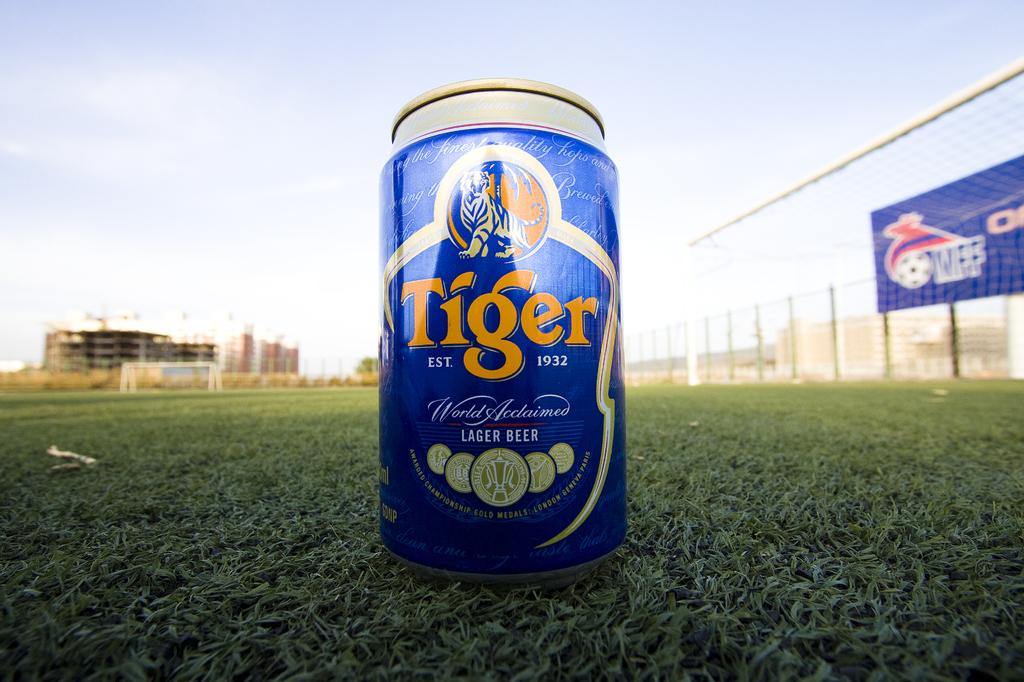What object can be seen on the ground in the image? There is a tin on the ground in the image. What type of barrier is present in the image? There is a fence in the image. What type of vegetation is visible in the image? There is grass in the image. What type of structures can be seen in the image? There are buildings in the image. What is hanging on the wall in the image? There is a poster in the image. What else can be seen in the image besides the mentioned objects? There are some objects in the image. What is visible in the background of the image? The sky is visible in the background of the image. How many women are walking with their partners in the image? There are no women or partners present in the image. What type of car is parked near the tin on the ground? There is no car present in the image. 